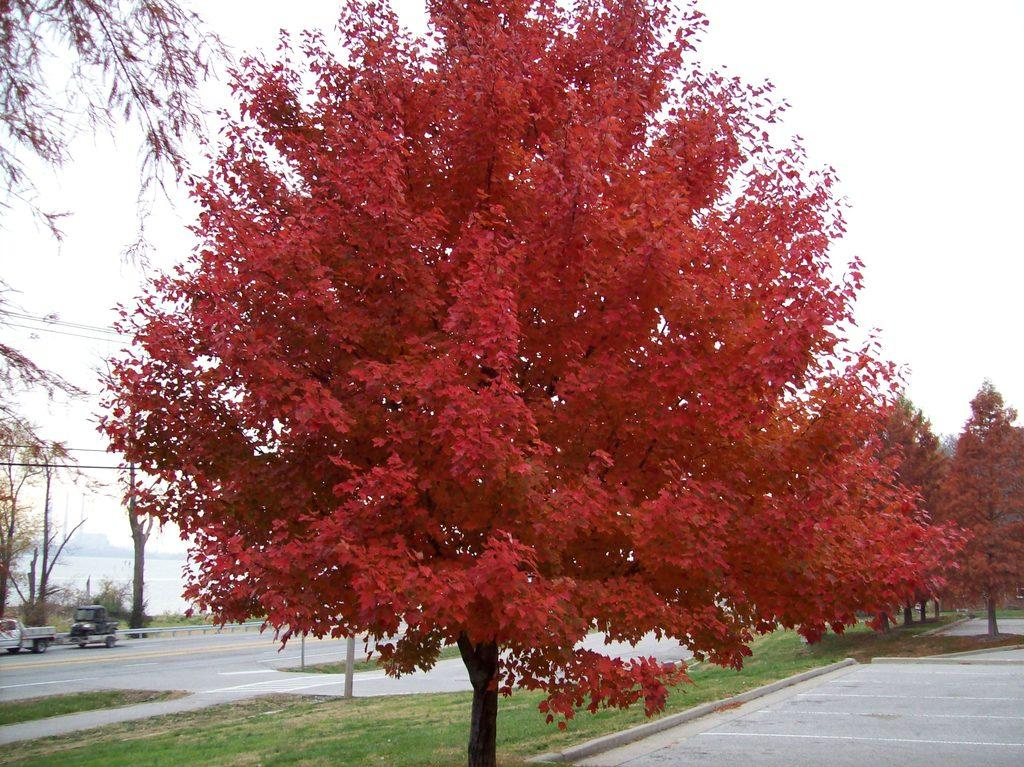What type of vegetation can be seen in the image? There are trees in the image. What is the color of some of the trees in the image? Some of the trees are red in color. What is happening on the road in the image? There are vehicles moving on the road in the image. What is the condition of the sky in the image? The sky is cloudy in the image. How many chickens are perched on the icicles in the image? There are no chickens or icicles present in the image. Is the cook preparing a meal in the image? There is no cook or meal preparation visible in the image. 